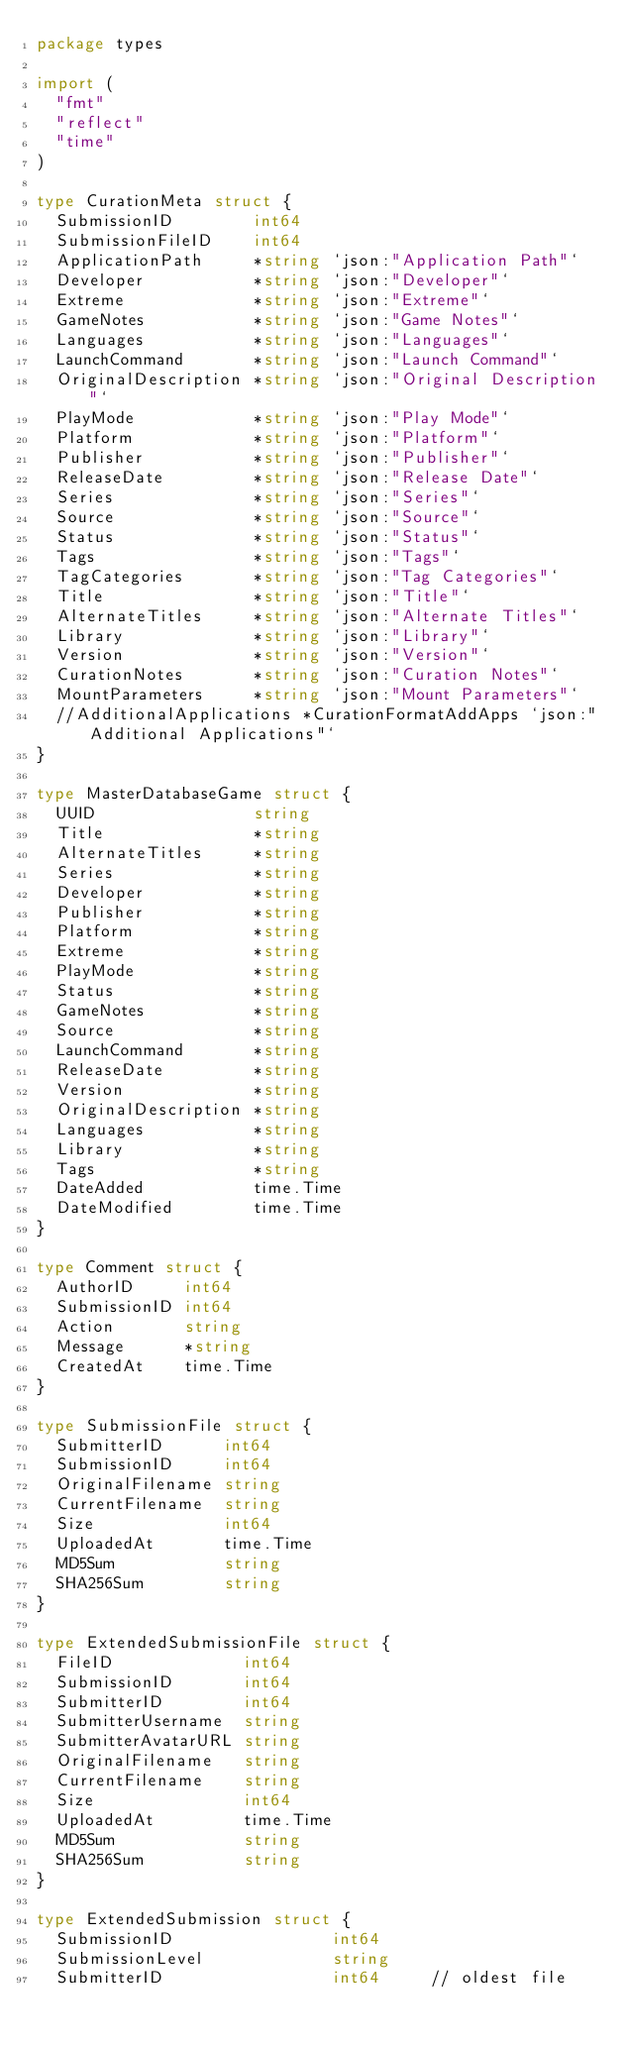<code> <loc_0><loc_0><loc_500><loc_500><_Go_>package types

import (
	"fmt"
	"reflect"
	"time"
)

type CurationMeta struct {
	SubmissionID        int64
	SubmissionFileID    int64
	ApplicationPath     *string `json:"Application Path"`
	Developer           *string `json:"Developer"`
	Extreme             *string `json:"Extreme"`
	GameNotes           *string `json:"Game Notes"`
	Languages           *string `json:"Languages"`
	LaunchCommand       *string `json:"Launch Command"`
	OriginalDescription *string `json:"Original Description"`
	PlayMode            *string `json:"Play Mode"`
	Platform            *string `json:"Platform"`
	Publisher           *string `json:"Publisher"`
	ReleaseDate         *string `json:"Release Date"`
	Series              *string `json:"Series"`
	Source              *string `json:"Source"`
	Status              *string `json:"Status"`
	Tags                *string `json:"Tags"`
	TagCategories       *string `json:"Tag Categories"`
	Title               *string `json:"Title"`
	AlternateTitles     *string `json:"Alternate Titles"`
	Library             *string `json:"Library"`
	Version             *string `json:"Version"`
	CurationNotes       *string `json:"Curation Notes"`
	MountParameters     *string `json:"Mount Parameters"`
	//AdditionalApplications *CurationFormatAddApps `json:"Additional Applications"`
}

type MasterDatabaseGame struct {
	UUID                string
	Title               *string
	AlternateTitles     *string
	Series              *string
	Developer           *string
	Publisher           *string
	Platform            *string
	Extreme             *string
	PlayMode            *string
	Status              *string
	GameNotes           *string
	Source              *string
	LaunchCommand       *string
	ReleaseDate         *string
	Version             *string
	OriginalDescription *string
	Languages           *string
	Library             *string
	Tags                *string
	DateAdded           time.Time
	DateModified        time.Time
}

type Comment struct {
	AuthorID     int64
	SubmissionID int64
	Action       string
	Message      *string
	CreatedAt    time.Time
}

type SubmissionFile struct {
	SubmitterID      int64
	SubmissionID     int64
	OriginalFilename string
	CurrentFilename  string
	Size             int64
	UploadedAt       time.Time
	MD5Sum           string
	SHA256Sum        string
}

type ExtendedSubmissionFile struct {
	FileID             int64
	SubmissionID       int64
	SubmitterID        int64
	SubmitterUsername  string
	SubmitterAvatarURL string
	OriginalFilename   string
	CurrentFilename    string
	Size               int64
	UploadedAt         time.Time
	MD5Sum             string
	SHA256Sum          string
}

type ExtendedSubmission struct {
	SubmissionID                int64
	SubmissionLevel             string
	SubmitterID                 int64     // oldest file</code> 